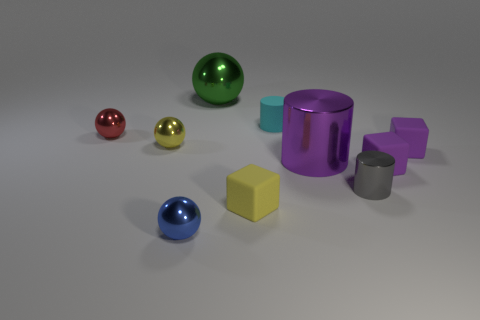Are there fewer cylinders that are to the left of the blue object than metallic things that are on the left side of the large green thing?
Your answer should be very brief. Yes. Does the yellow metallic thing have the same shape as the red thing?
Offer a very short reply. Yes. How many other objects are the same size as the gray object?
Make the answer very short. 7. What number of objects are shiny spheres that are behind the big purple metallic thing or tiny things that are behind the tiny gray thing?
Make the answer very short. 6. How many small cyan things are the same shape as the big purple thing?
Offer a very short reply. 1. The thing that is in front of the gray thing and behind the blue object is made of what material?
Keep it short and to the point. Rubber. There is a green thing; how many metal objects are on the right side of it?
Your answer should be very brief. 2. What number of big yellow shiny blocks are there?
Your answer should be compact. 0. Does the green ball have the same size as the blue thing?
Offer a terse response. No. There is a yellow thing that is right of the big thing that is behind the yellow metallic ball; are there any purple matte things that are to the left of it?
Provide a succinct answer. No. 